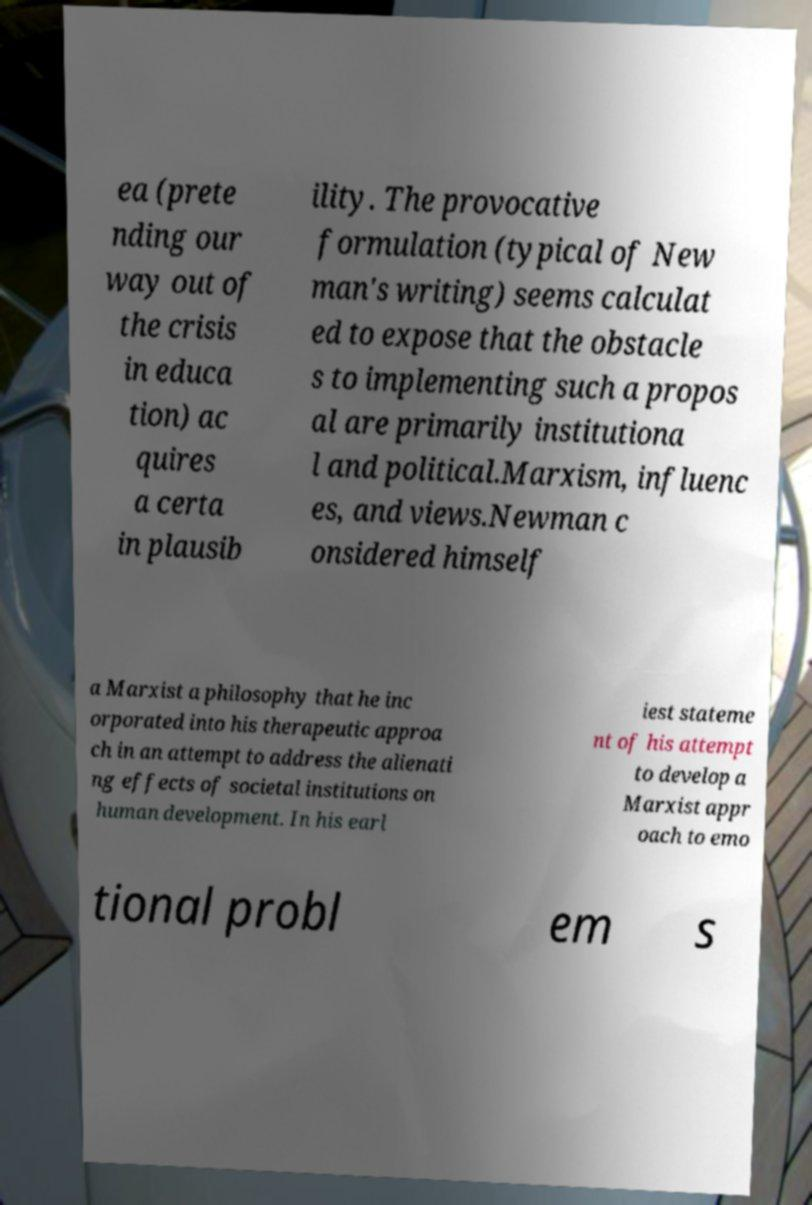For documentation purposes, I need the text within this image transcribed. Could you provide that? ea (prete nding our way out of the crisis in educa tion) ac quires a certa in plausib ility. The provocative formulation (typical of New man's writing) seems calculat ed to expose that the obstacle s to implementing such a propos al are primarily institutiona l and political.Marxism, influenc es, and views.Newman c onsidered himself a Marxist a philosophy that he inc orporated into his therapeutic approa ch in an attempt to address the alienati ng effects of societal institutions on human development. In his earl iest stateme nt of his attempt to develop a Marxist appr oach to emo tional probl em s 